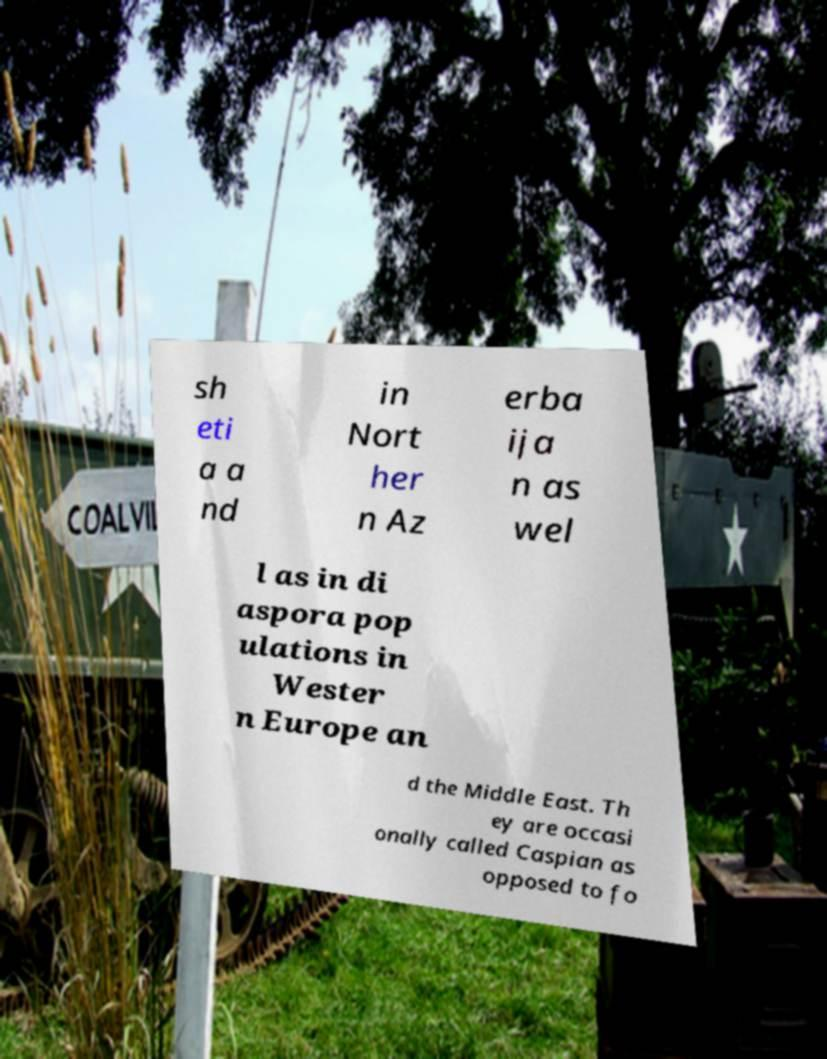What messages or text are displayed in this image? I need them in a readable, typed format. sh eti a a nd in Nort her n Az erba ija n as wel l as in di aspora pop ulations in Wester n Europe an d the Middle East. Th ey are occasi onally called Caspian as opposed to fo 